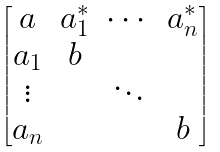<formula> <loc_0><loc_0><loc_500><loc_500>\begin{bmatrix} a & a _ { 1 } ^ { * } & \cdots & a _ { n } ^ { * } \\ a _ { 1 } & b & & \\ \vdots & & \ddots & \\ a _ { n } & & & b \end{bmatrix}</formula> 